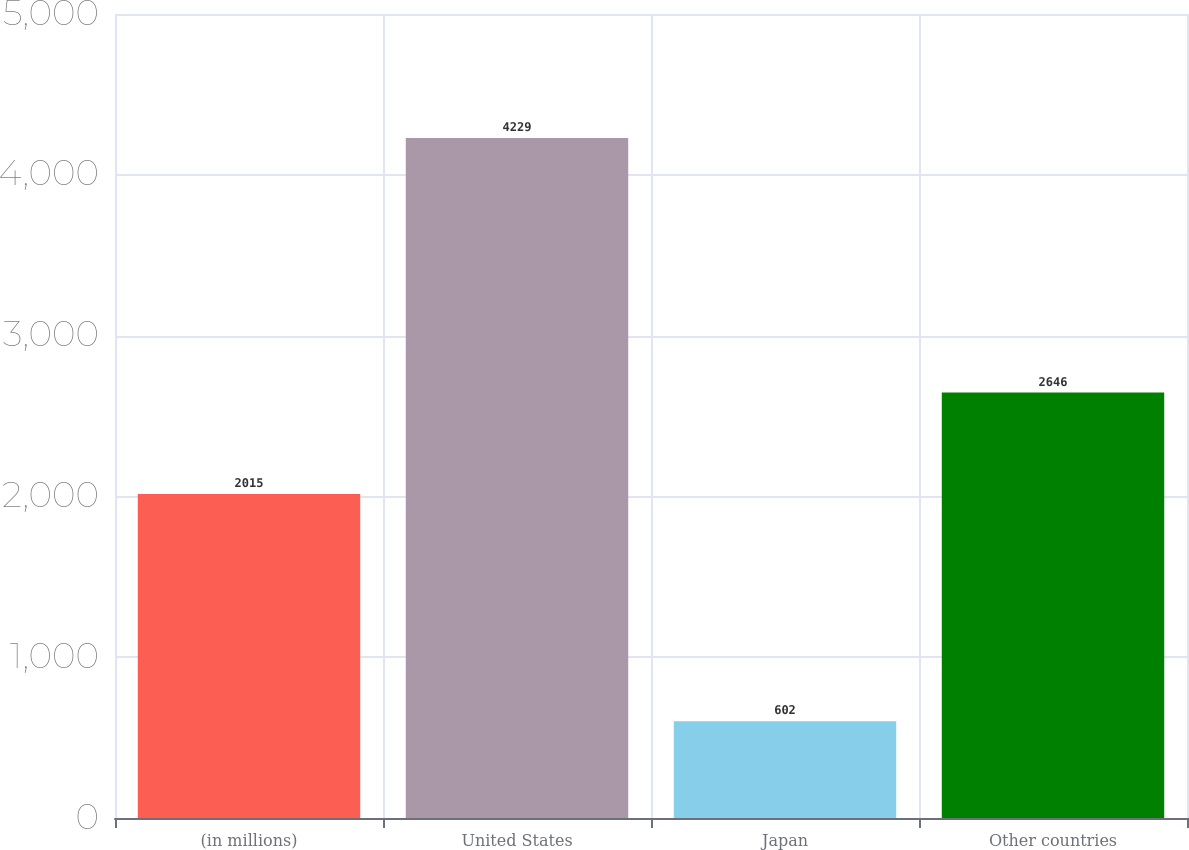<chart> <loc_0><loc_0><loc_500><loc_500><bar_chart><fcel>(in millions)<fcel>United States<fcel>Japan<fcel>Other countries<nl><fcel>2015<fcel>4229<fcel>602<fcel>2646<nl></chart> 